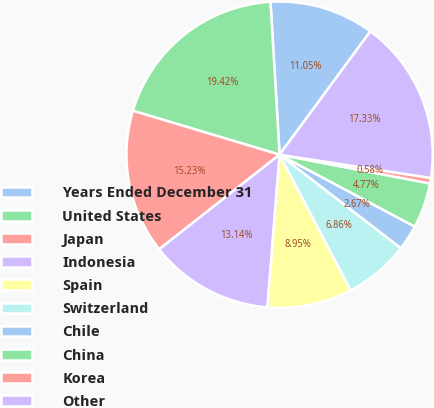<chart> <loc_0><loc_0><loc_500><loc_500><pie_chart><fcel>Years Ended December 31<fcel>United States<fcel>Japan<fcel>Indonesia<fcel>Spain<fcel>Switzerland<fcel>Chile<fcel>China<fcel>Korea<fcel>Other<nl><fcel>11.05%<fcel>19.42%<fcel>15.23%<fcel>13.14%<fcel>8.95%<fcel>6.86%<fcel>2.67%<fcel>4.77%<fcel>0.58%<fcel>17.33%<nl></chart> 